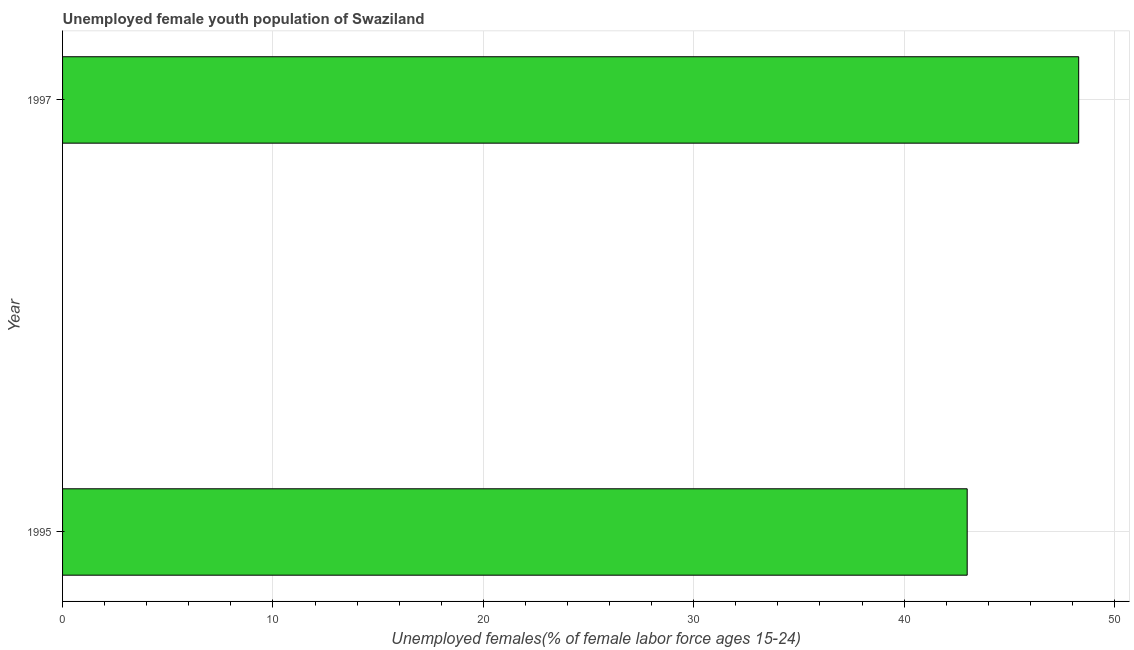Does the graph contain any zero values?
Keep it short and to the point. No. Does the graph contain grids?
Your answer should be very brief. Yes. What is the title of the graph?
Provide a short and direct response. Unemployed female youth population of Swaziland. What is the label or title of the X-axis?
Ensure brevity in your answer.  Unemployed females(% of female labor force ages 15-24). What is the label or title of the Y-axis?
Your answer should be very brief. Year. What is the unemployed female youth in 1997?
Your response must be concise. 48.3. Across all years, what is the maximum unemployed female youth?
Ensure brevity in your answer.  48.3. What is the sum of the unemployed female youth?
Ensure brevity in your answer.  91.3. What is the average unemployed female youth per year?
Give a very brief answer. 45.65. What is the median unemployed female youth?
Offer a terse response. 45.65. In how many years, is the unemployed female youth greater than 38 %?
Ensure brevity in your answer.  2. What is the ratio of the unemployed female youth in 1995 to that in 1997?
Give a very brief answer. 0.89. In how many years, is the unemployed female youth greater than the average unemployed female youth taken over all years?
Provide a short and direct response. 1. Are all the bars in the graph horizontal?
Provide a succinct answer. Yes. Are the values on the major ticks of X-axis written in scientific E-notation?
Your response must be concise. No. What is the Unemployed females(% of female labor force ages 15-24) of 1997?
Offer a terse response. 48.3. What is the difference between the Unemployed females(% of female labor force ages 15-24) in 1995 and 1997?
Offer a very short reply. -5.3. What is the ratio of the Unemployed females(% of female labor force ages 15-24) in 1995 to that in 1997?
Provide a succinct answer. 0.89. 